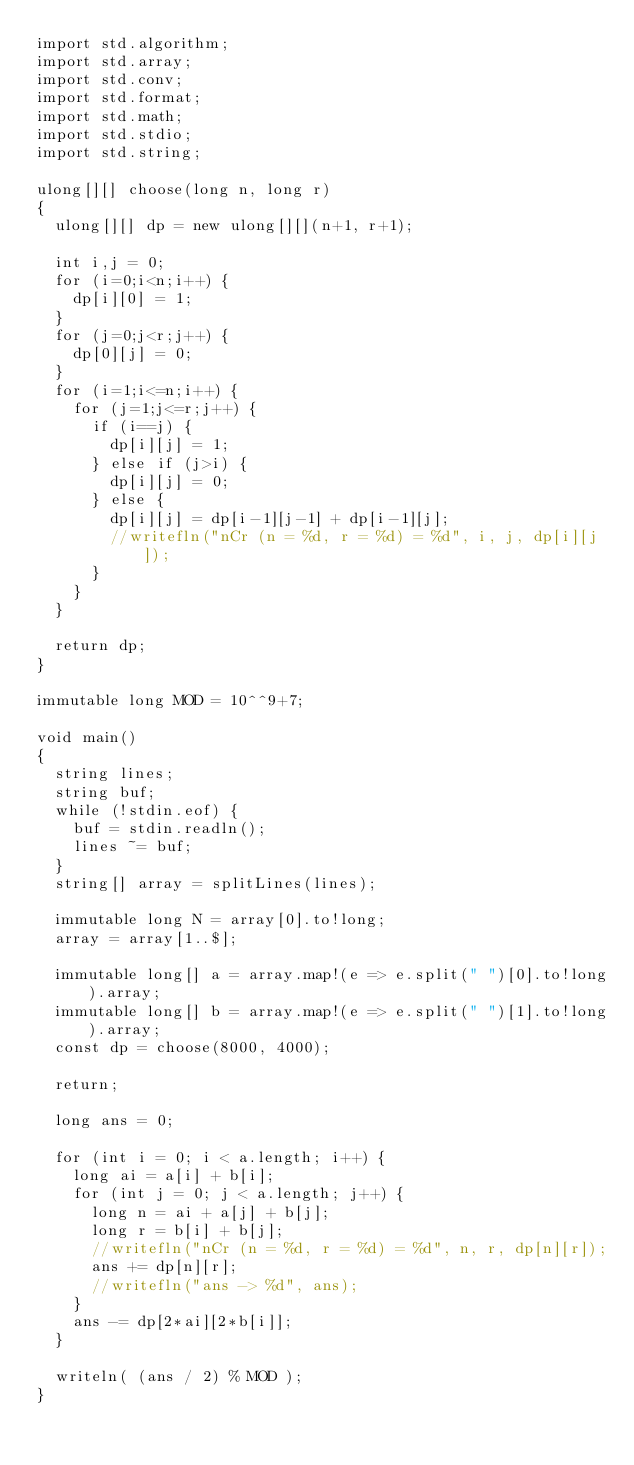Convert code to text. <code><loc_0><loc_0><loc_500><loc_500><_D_>import std.algorithm;
import std.array;
import std.conv;
import std.format;
import std.math;
import std.stdio;
import std.string;

ulong[][] choose(long n, long r)
{
  ulong[][] dp = new ulong[][](n+1, r+1);

  int i,j = 0;
  for (i=0;i<n;i++) {
    dp[i][0] = 1;
  }
  for (j=0;j<r;j++) {
    dp[0][j] = 0;
  }
  for (i=1;i<=n;i++) {
    for (j=1;j<=r;j++) {
      if (i==j) {
        dp[i][j] = 1;
      } else if (j>i) {
        dp[i][j] = 0;
      } else {
        dp[i][j] = dp[i-1][j-1] + dp[i-1][j];
        //writefln("nCr (n = %d, r = %d) = %d", i, j, dp[i][j]);
      }
    }
  }

  return dp;
}

immutable long MOD = 10^^9+7;

void main()
{
  string lines;
  string buf;
  while (!stdin.eof) {
    buf = stdin.readln();
    lines ~= buf;
  }
  string[] array = splitLines(lines);

  immutable long N = array[0].to!long;
  array = array[1..$];

  immutable long[] a = array.map!(e => e.split(" ")[0].to!long).array;
  immutable long[] b = array.map!(e => e.split(" ")[1].to!long).array;
  const dp = choose(8000, 4000);

  return;

  long ans = 0;

  for (int i = 0; i < a.length; i++) {
    long ai = a[i] + b[i];
    for (int j = 0; j < a.length; j++) {
      long n = ai + a[j] + b[j];
      long r = b[i] + b[j];
      //writefln("nCr (n = %d, r = %d) = %d", n, r, dp[n][r]);
      ans += dp[n][r];
      //writefln("ans -> %d", ans);
    }
    ans -= dp[2*ai][2*b[i]];
  }

  writeln( (ans / 2) % MOD );
}
</code> 